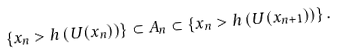Convert formula to latex. <formula><loc_0><loc_0><loc_500><loc_500>\left \{ x _ { n } > h \left ( U ( x _ { n } ) \right ) \right \} \subset A _ { n } \subset \left \{ x _ { n } > h \left ( U ( x _ { n + 1 } ) \right ) \right \} .</formula> 